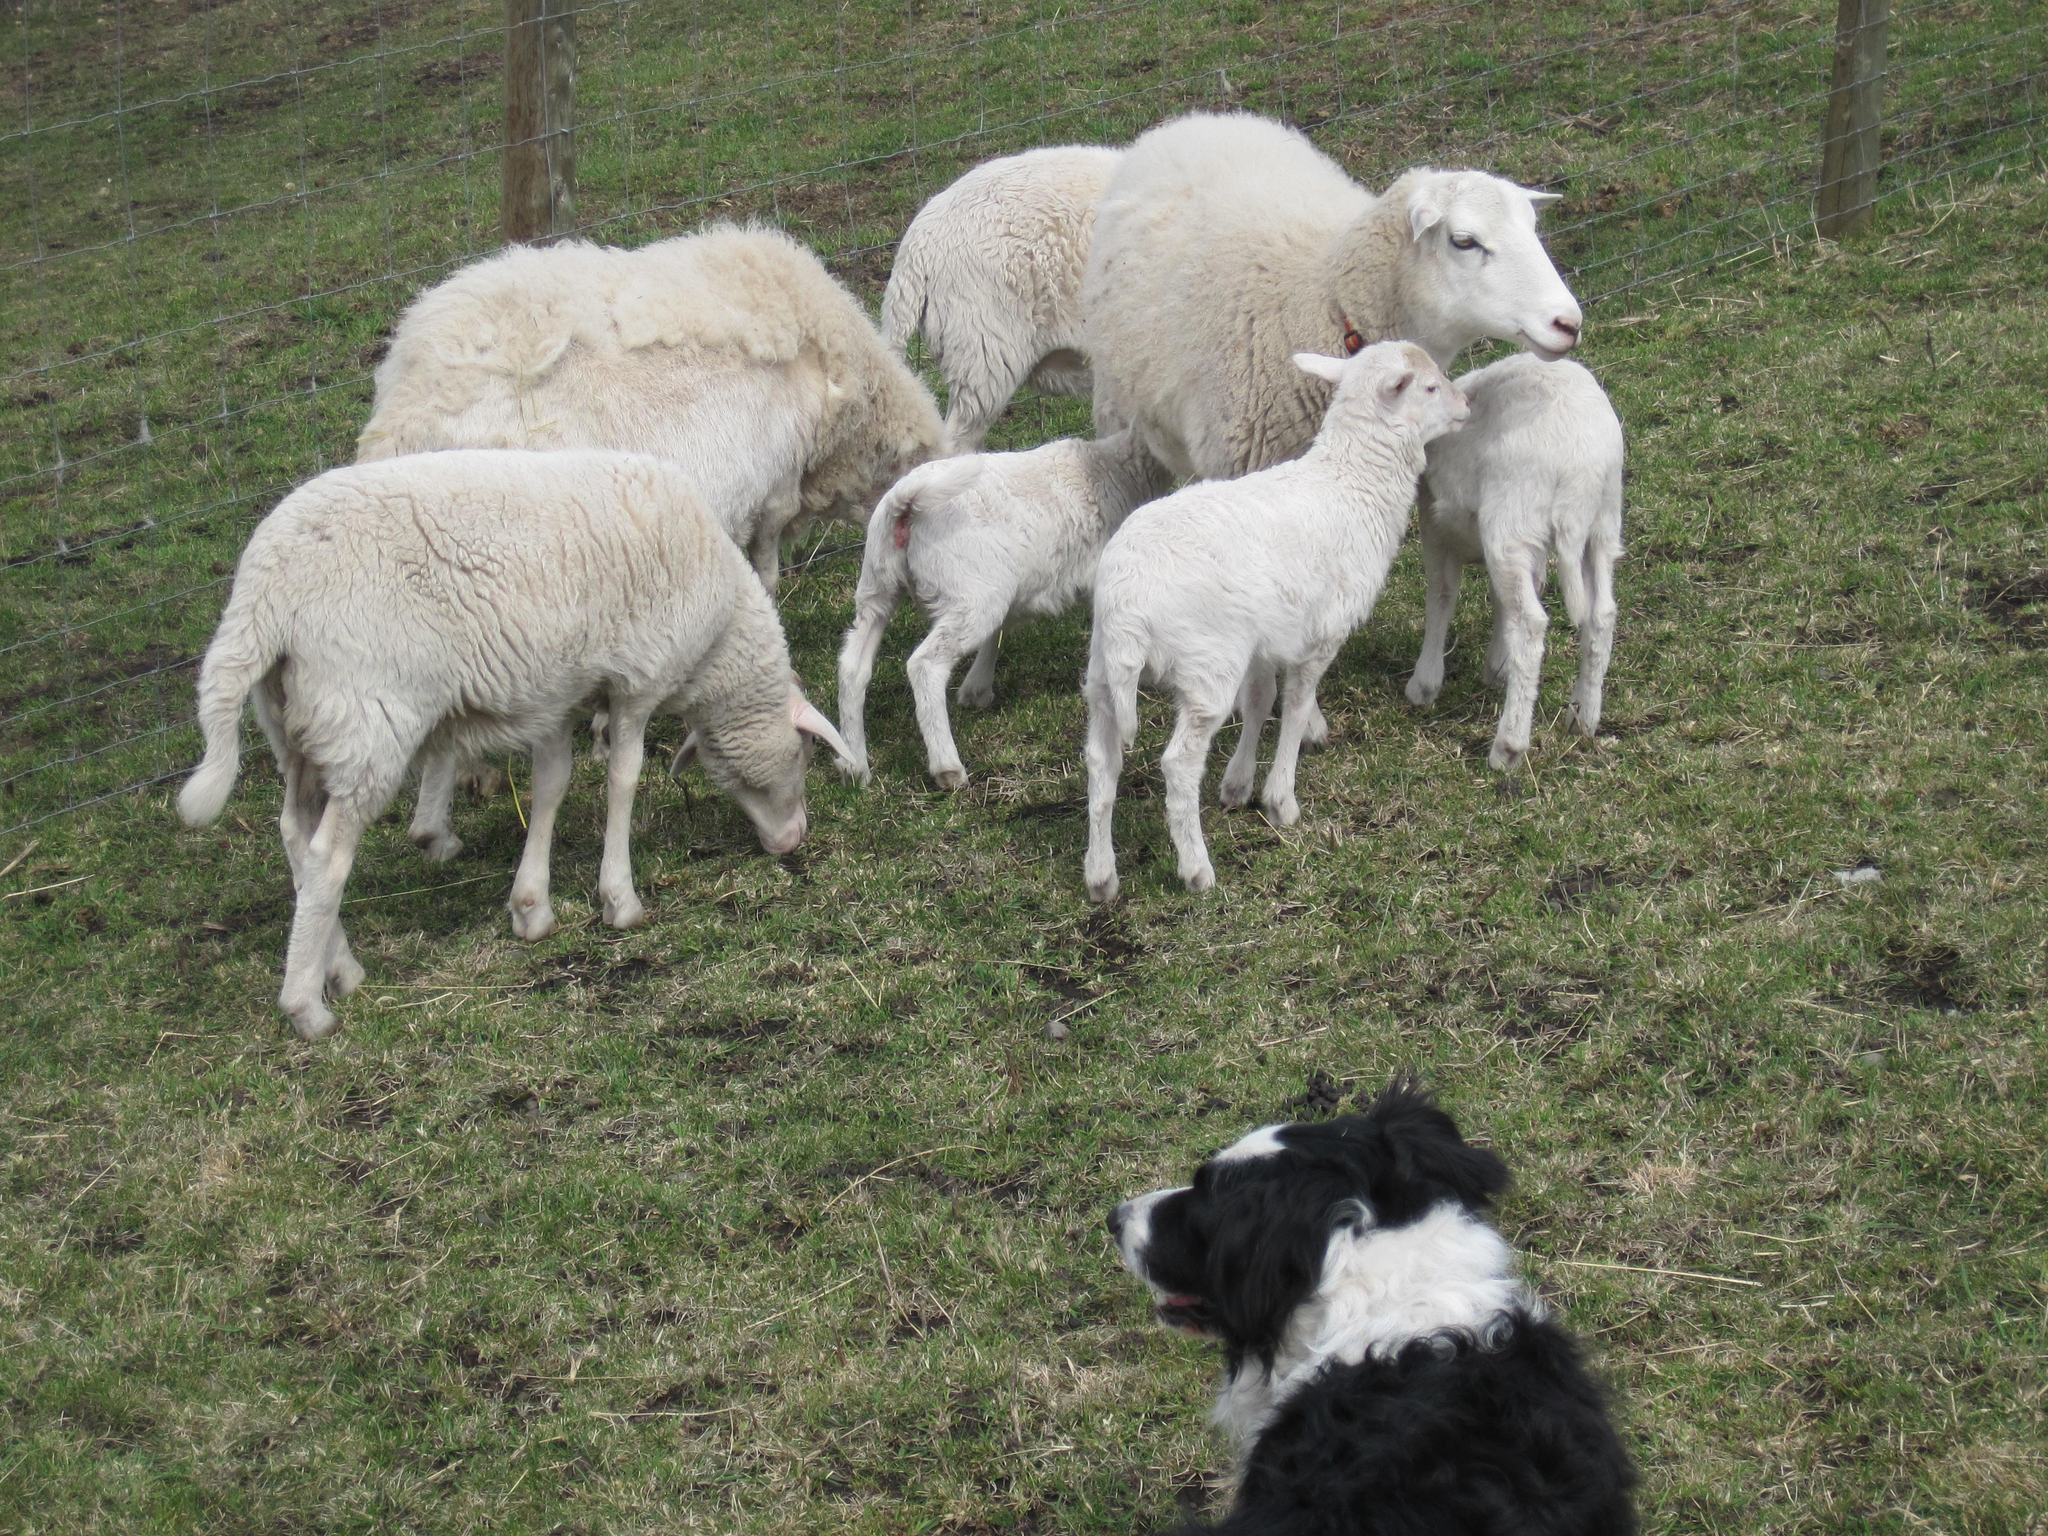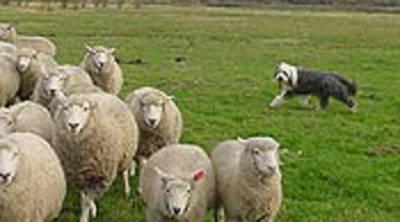The first image is the image on the left, the second image is the image on the right. Considering the images on both sides, is "An image shows a man standing and holding onto something useful for herding the sheep in the picture." valid? Answer yes or no. No. The first image is the image on the left, the second image is the image on the right. Assess this claim about the two images: "A person is standing with the dog and sheep in one of the images.". Correct or not? Answer yes or no. No. 